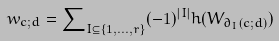Convert formula to latex. <formula><loc_0><loc_0><loc_500><loc_500>w _ { c ; d } = \sum \nolimits _ { I \subseteq \{ 1 , \dots , r \} } ( - 1 ) ^ { | I | } h ( W _ { \partial _ { I } ( c ; d ) } )</formula> 